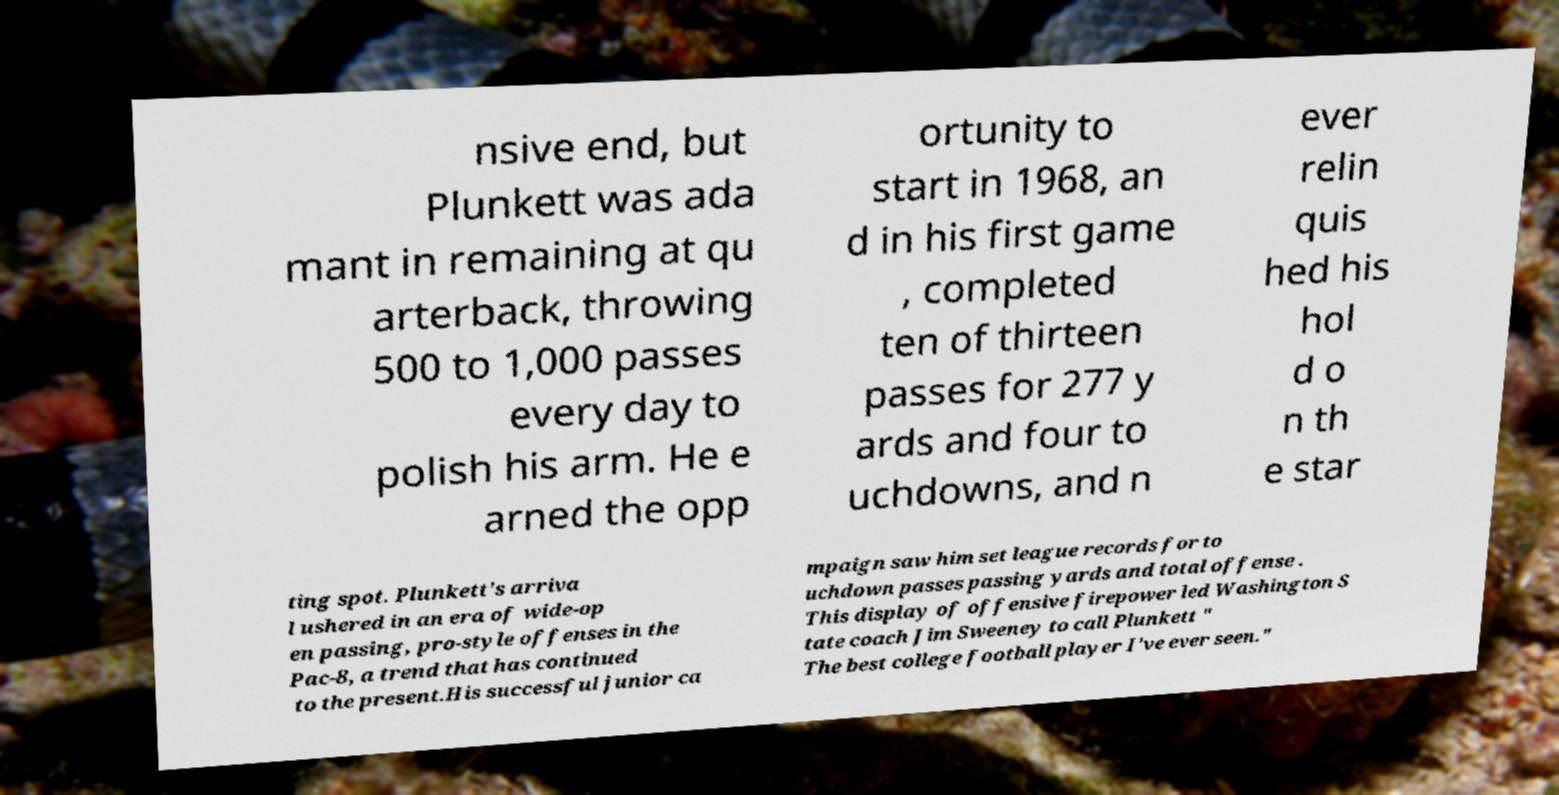There's text embedded in this image that I need extracted. Can you transcribe it verbatim? nsive end, but Plunkett was ada mant in remaining at qu arterback, throwing 500 to 1,000 passes every day to polish his arm. He e arned the opp ortunity to start in 1968, an d in his first game , completed ten of thirteen passes for 277 y ards and four to uchdowns, and n ever relin quis hed his hol d o n th e star ting spot. Plunkett's arriva l ushered in an era of wide-op en passing, pro-style offenses in the Pac-8, a trend that has continued to the present.His successful junior ca mpaign saw him set league records for to uchdown passes passing yards and total offense . This display of offensive firepower led Washington S tate coach Jim Sweeney to call Plunkett " The best college football player I've ever seen." 